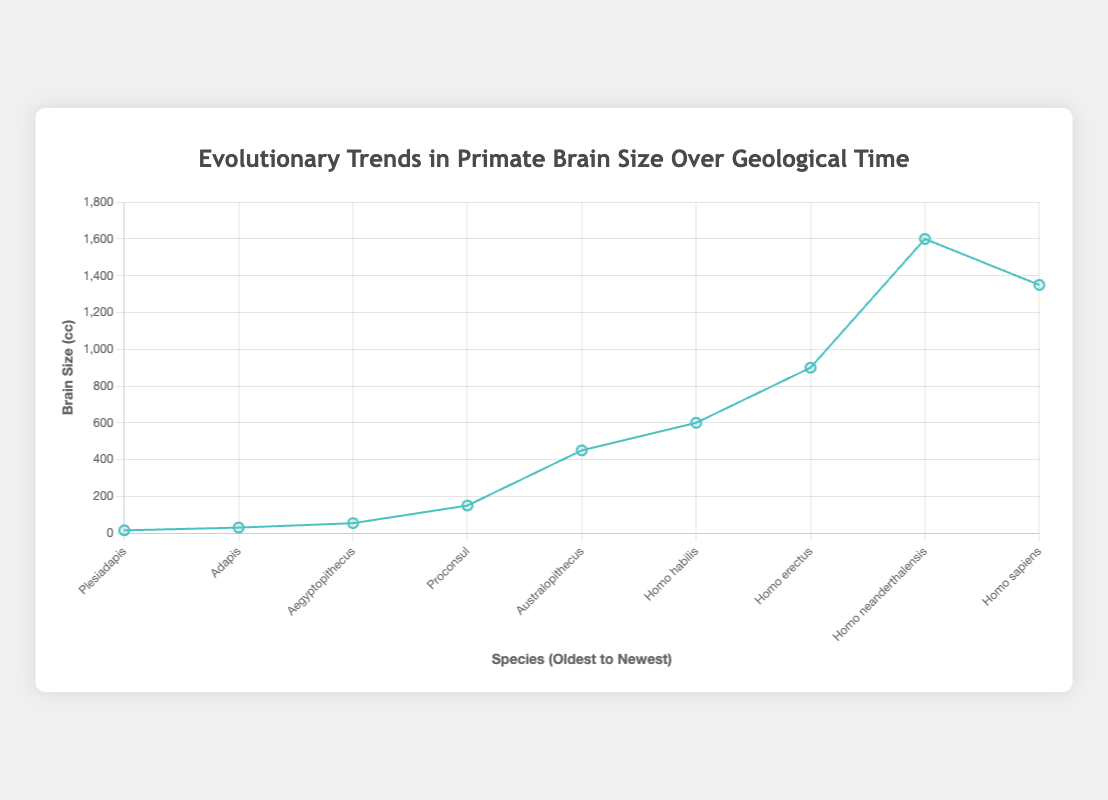Which species has the largest brain size in the dataset? The dataset shows that Homo neanderthalensis, located in the Late Pleistocene epoch, has the largest brain size at 1600 cc.
Answer: Homo neanderthalensis How does the brain size of Homo sapiens compare to Homo habilis? Homo sapiens has a brain size of 1350 cc, while Homo habilis has a brain size of 600 cc. Therefore, the brain size of Homo sapiens is 750 cc larger than that of Homo habilis.
Answer: Homo sapiens has a brain size 750 cc larger than Homo habilis What's the average brain size of the species from the Paleocene to the Pliocene periods? To find the average brain size for species from the Paleocene (Plesiadapis, 15 cc), Eocene (Adapis, 30 cc), Oligocene (Aegyptopithecus, 54 cc), Miocene (Proconsul, 150 cc), and Pliocene (Australopithecus, 450 cc), you sum the brain sizes (15 + 30 + 54 + 150 + 450 = 699) and divide by the number of species (5). Thus, the average brain size is 699/5 = 139.8 cc
Answer: 139.8 cc What is the trend in brain size from the Early Pleistocene to the Late Pleistocene? The brain sizes for the Pleistocene are as follows: Early Pleistocene (Homo habilis, 600 cc), Middle Pleistocene (Homo erectus, 900 cc), Late Pleistocene (Homo neanderthalensis, 1600 cc). We observe an increasing trend: 600 cc to 900 cc to 1600 cc.
Answer: Increasing trend How many species have a brain size of 900 cc or larger? The species with brain sizes of 900 cc or larger are Homo erectus (900 cc), Homo neanderthalensis (1600 cc), and Homo sapiens (1350 cc). Therefore, there are 3 species with brain sizes of 900 cc or larger.
Answer: 3 species Which species had the highest increase in brain size compared to its predecessor? By comparing consecutive species: Plesiadapis to Adapis (15 to 30 cc, +15 cc), Adapis to Aegyptopithecus (30 to 54 cc, +24 cc), Aegyptopithecus to Proconsul (54 to 150 cc, +96 cc), Proconsul to Australopithecus (150 to 450 cc, +300 cc), Australopithecus to Homo habilis (450 to 600 cc, +150 cc), Homo habilis to Homo erectus (600 to 900 cc, +300 cc), Homo erectus to Homo neanderthalensis (900 to 1600 cc, +700 cc), Homo neanderthalensis to Homo sapiens (1600 to 1350 cc, -250 cc). The highest increase is from Homo erectus to Homo neanderthalensis, with +700 cc.
Answer: Homo neanderthalensis What is the median brain size in the dataset? To determine the median, we need to sort the brain sizes in ascending order: 15, 30, 54, 150, 450, 600, 900, 1350, 1600. Since there are 9 data points, the median is the 5th value in this sorted list, which is 450 cc.
Answer: 450 cc 